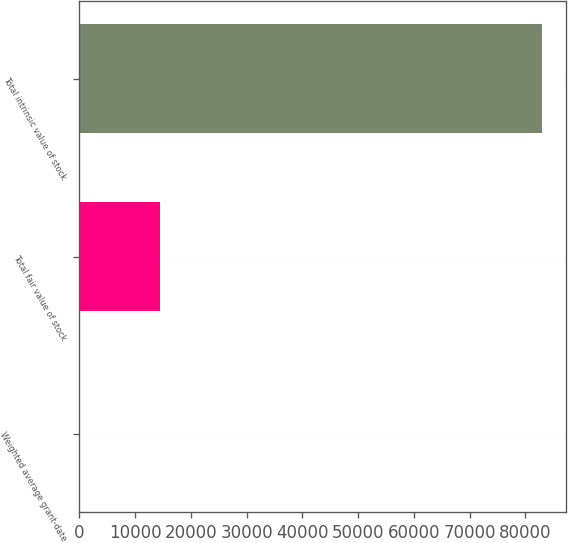<chart> <loc_0><loc_0><loc_500><loc_500><bar_chart><fcel>Weighted average grant-date<fcel>Total fair value of stock<fcel>Total intrinsic value of stock<nl><fcel>12.54<fcel>14506<fcel>83089<nl></chart> 